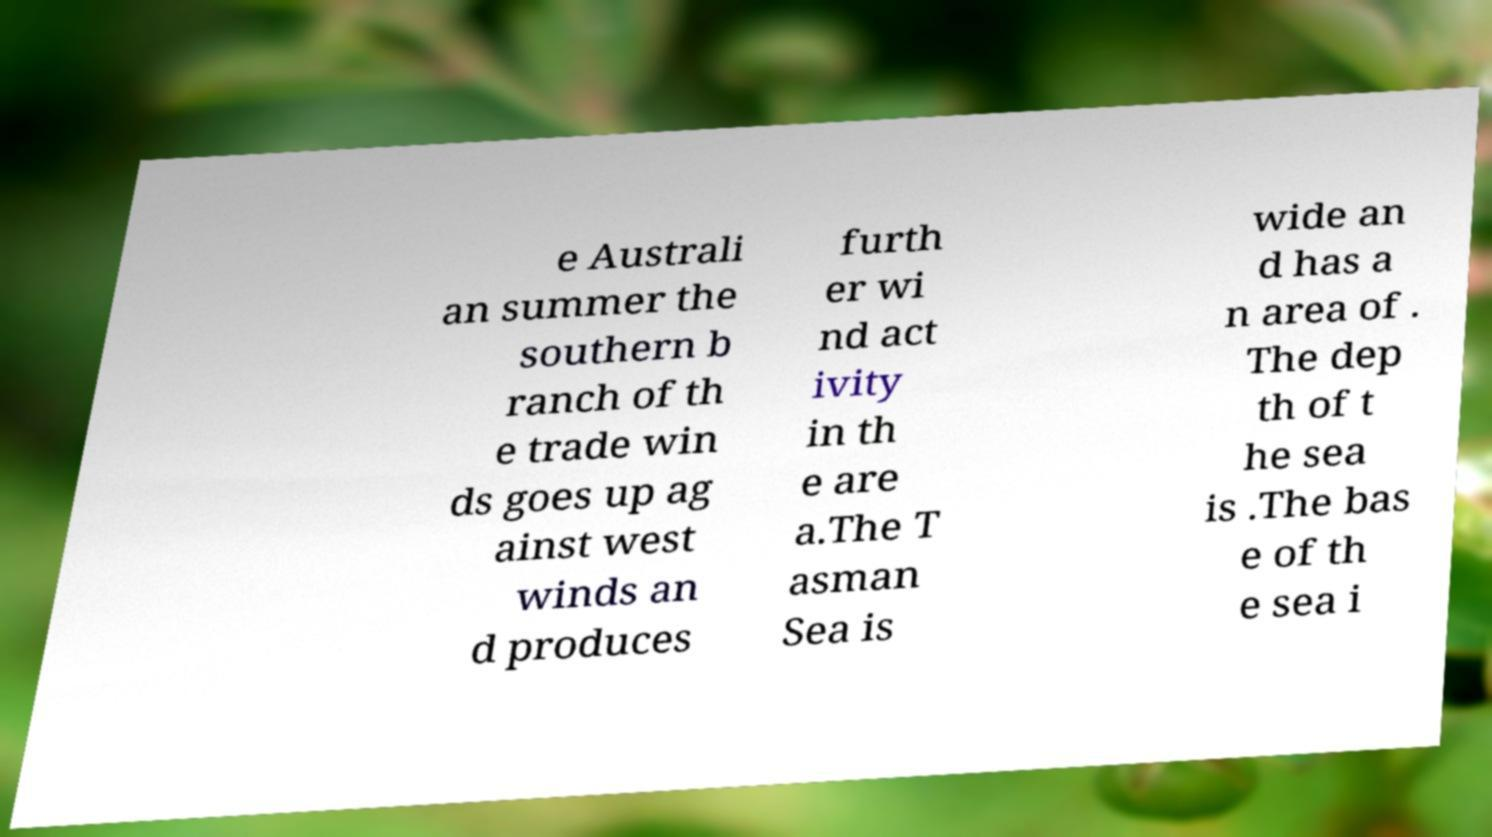Please identify and transcribe the text found in this image. e Australi an summer the southern b ranch of th e trade win ds goes up ag ainst west winds an d produces furth er wi nd act ivity in th e are a.The T asman Sea is wide an d has a n area of . The dep th of t he sea is .The bas e of th e sea i 